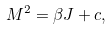<formula> <loc_0><loc_0><loc_500><loc_500>M ^ { 2 } = \beta J + c ,</formula> 